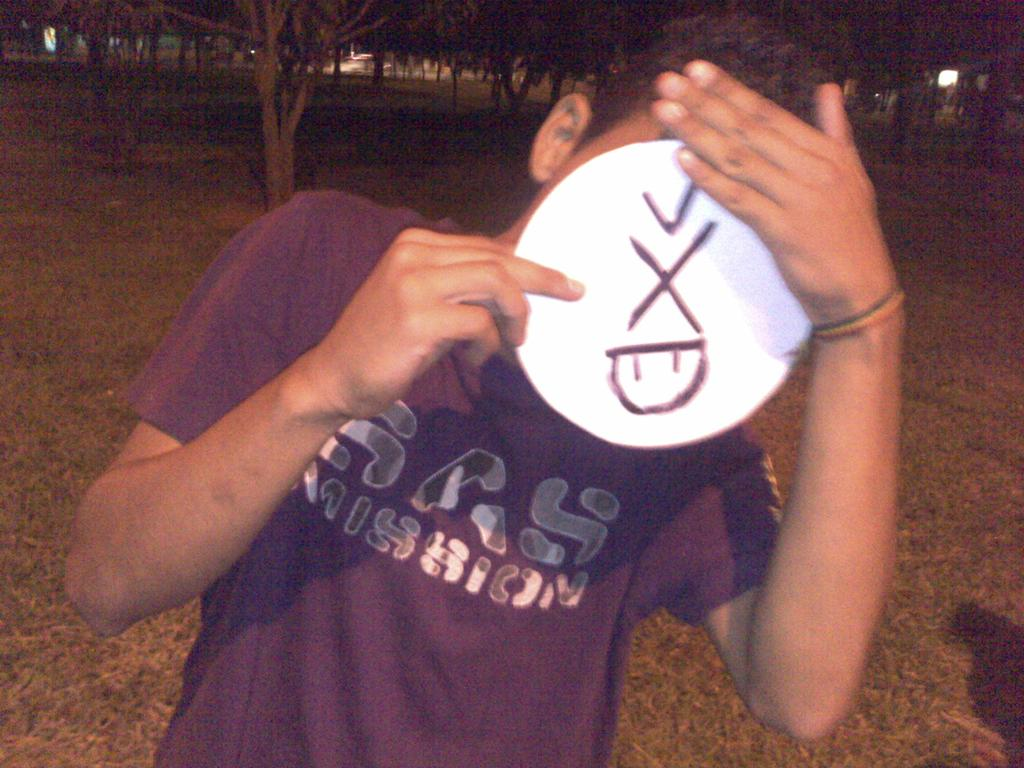Provide a one-sentence caption for the provided image. Person wearing a purple shirt that says SAS Mission covering their face. 